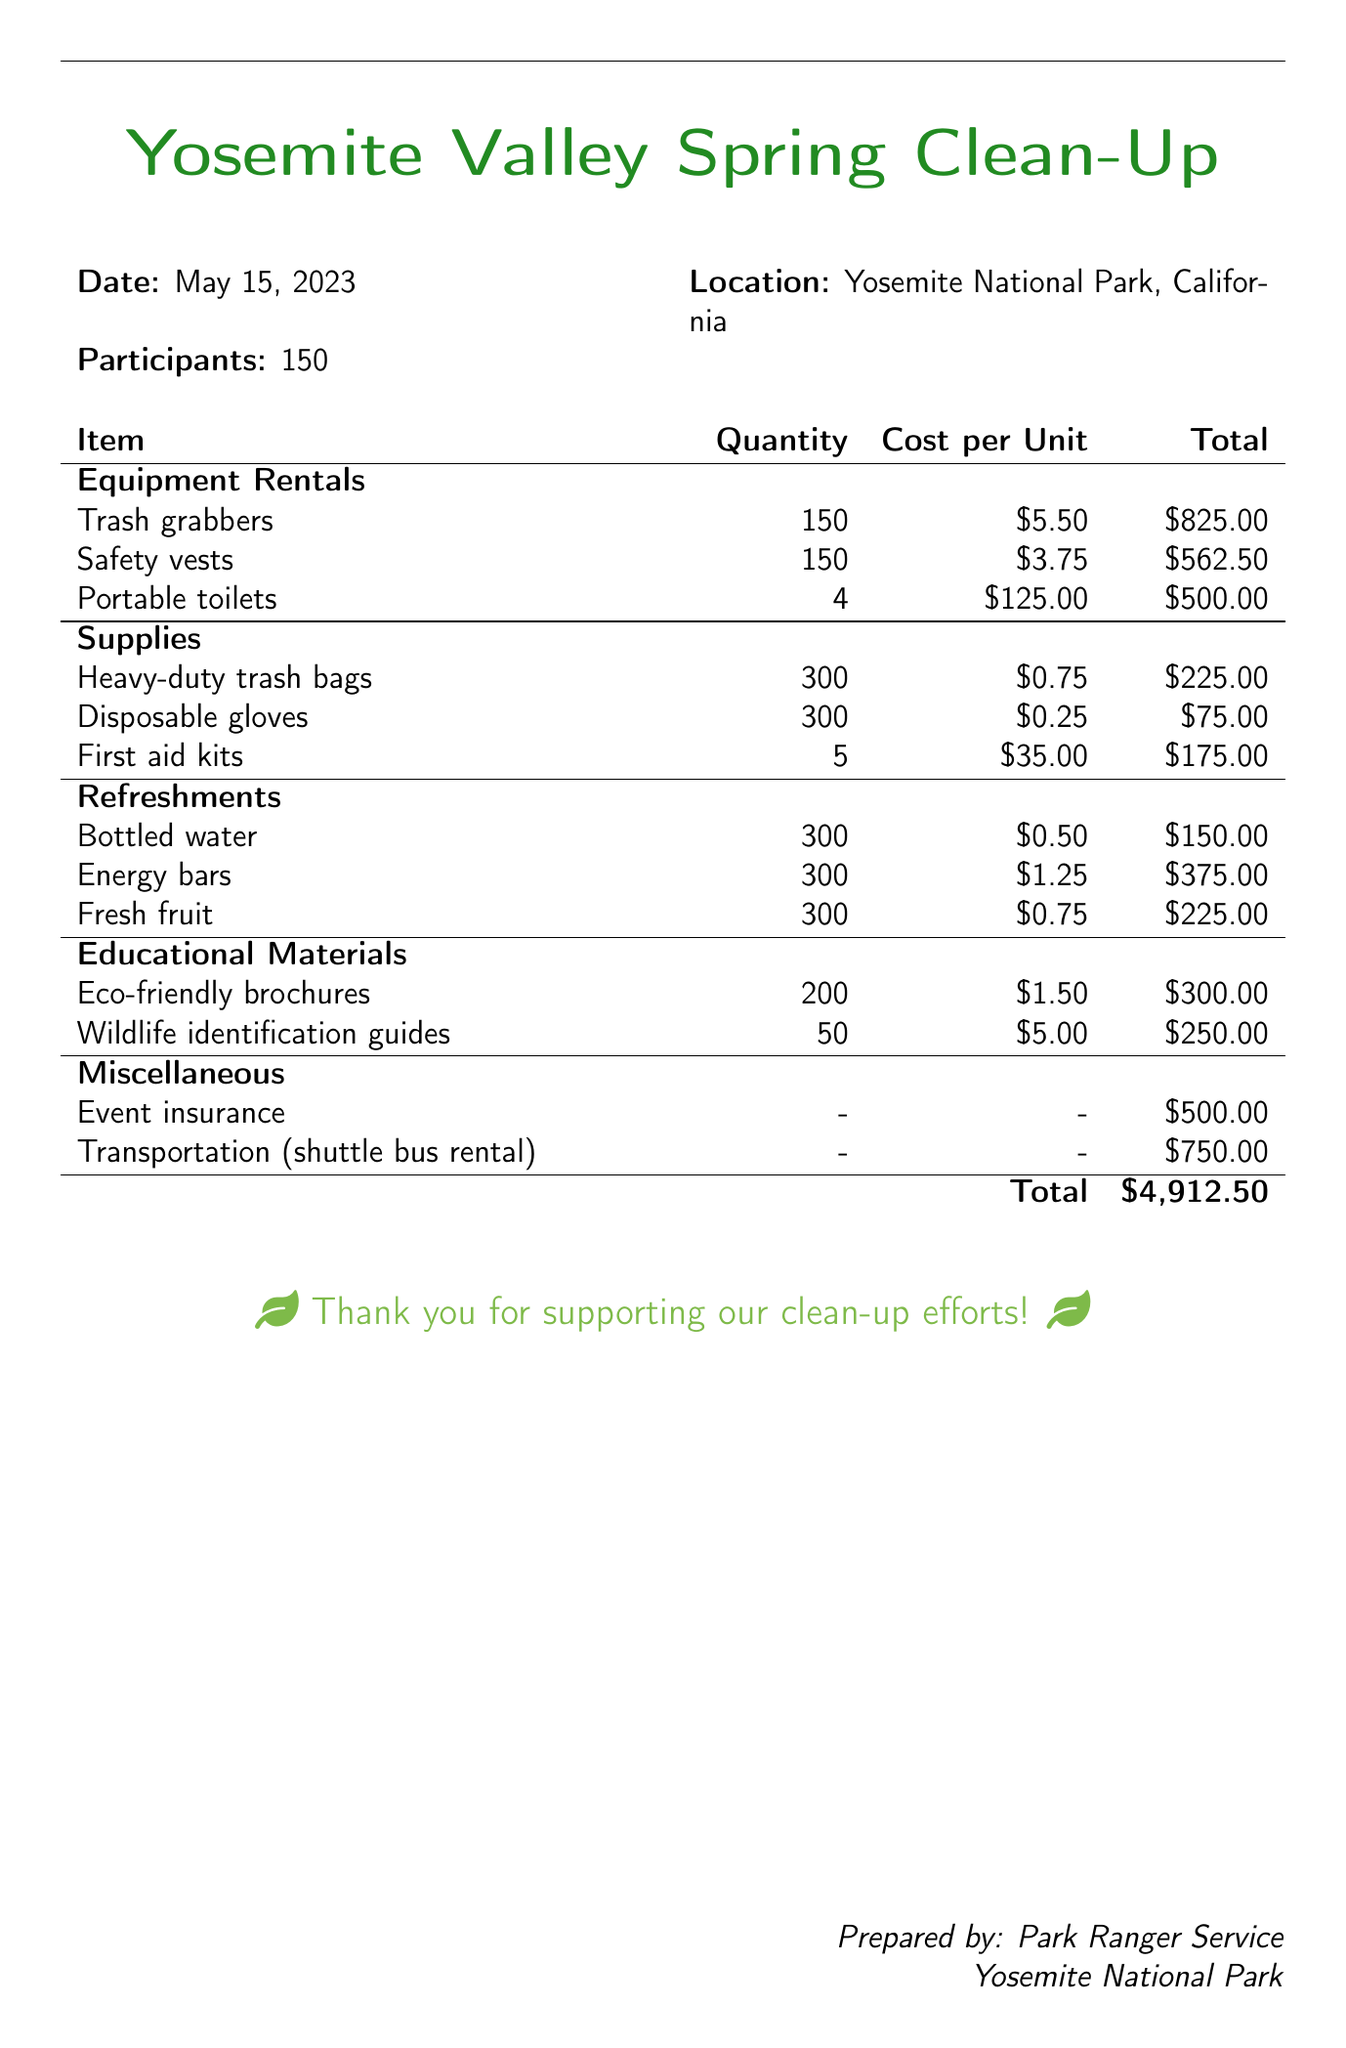what is the date of the event? The date of the clean-up event is explicitly stated in the document.
Answer: May 15, 2023 how many participants were there? The number of participants at the event is provided in the document.
Answer: 150 what is the total cost of equipment rentals? The total cost for equipment rentals is detailed through individual item costs summed together.
Answer: $1,887.50 which item had the highest cost? To find the highest cost item, we compare the totals of all listed items in the document.
Answer: Trash grabbers how many portable toilets were rented? The number of portable toilets rented is specified directly in the document.
Answer: 4 what was spent on refreshments? The total cost for refreshments can be calculated from the items listed under that section of the document.
Answer: $750.00 how many eco-friendly brochures were printed? The quantity of eco-friendly brochures is detailed in the educational materials section.
Answer: 200 what is the total amount spent on educational materials? The total cost for educational materials is found by adding the costs of the brochures and guides.
Answer: $550.00 what miscellaneous item cost $750? The document specifies the cost of one of the miscellaneous items, which is stated explicitly.
Answer: Transportation (shuttle bus rental) 